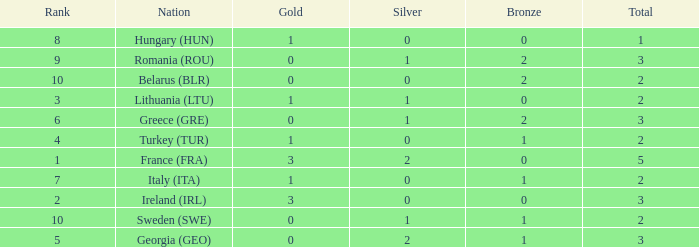What's the total number of bronze medals for Sweden (SWE) having less than 1 gold and silver? 0.0. 